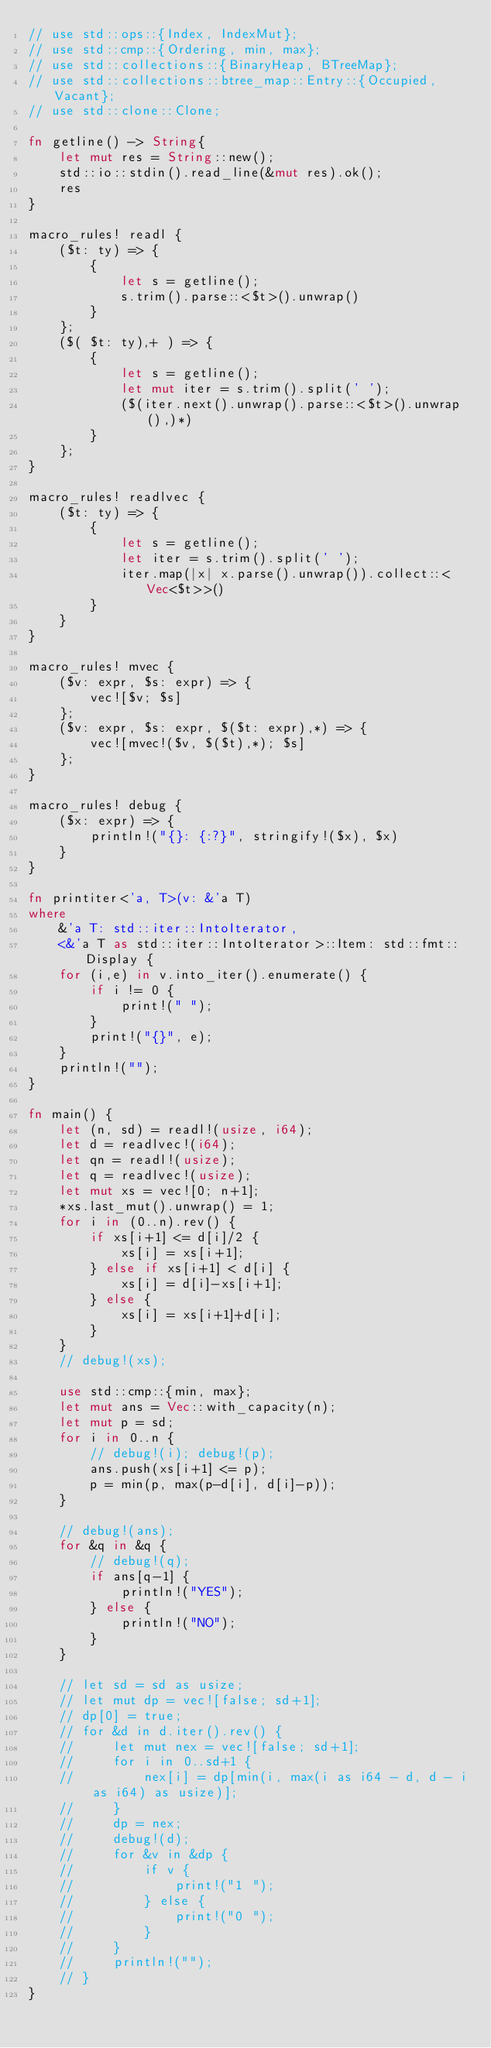Convert code to text. <code><loc_0><loc_0><loc_500><loc_500><_Rust_>// use std::ops::{Index, IndexMut};
// use std::cmp::{Ordering, min, max};
// use std::collections::{BinaryHeap, BTreeMap};
// use std::collections::btree_map::Entry::{Occupied, Vacant};
// use std::clone::Clone;

fn getline() -> String{
    let mut res = String::new();
    std::io::stdin().read_line(&mut res).ok();
    res
}

macro_rules! readl {
    ($t: ty) => {
        {
            let s = getline();
            s.trim().parse::<$t>().unwrap()
        }
    };
    ($( $t: ty),+ ) => {
        {
            let s = getline();
            let mut iter = s.trim().split(' ');
            ($(iter.next().unwrap().parse::<$t>().unwrap(),)*) 
        }
    };
}

macro_rules! readlvec {
    ($t: ty) => {
        {
            let s = getline();
            let iter = s.trim().split(' ');
            iter.map(|x| x.parse().unwrap()).collect::<Vec<$t>>()
        }
    }
}

macro_rules! mvec {
    ($v: expr, $s: expr) => {
        vec![$v; $s]
    };
    ($v: expr, $s: expr, $($t: expr),*) => {
        vec![mvec!($v, $($t),*); $s]
    };
}

macro_rules! debug {
    ($x: expr) => {
        println!("{}: {:?}", stringify!($x), $x)
    }
}

fn printiter<'a, T>(v: &'a T)
where
    &'a T: std::iter::IntoIterator, 
    <&'a T as std::iter::IntoIterator>::Item: std::fmt::Display {
    for (i,e) in v.into_iter().enumerate() {
        if i != 0 {
            print!(" ");
        }
        print!("{}", e);
    }
    println!("");
}

fn main() {
    let (n, sd) = readl!(usize, i64);
    let d = readlvec!(i64);
    let qn = readl!(usize);
    let q = readlvec!(usize);
    let mut xs = vec![0; n+1];
    *xs.last_mut().unwrap() = 1;
    for i in (0..n).rev() {
        if xs[i+1] <= d[i]/2 {
            xs[i] = xs[i+1];
        } else if xs[i+1] < d[i] {
            xs[i] = d[i]-xs[i+1];
        } else {
            xs[i] = xs[i+1]+d[i];
        }
    }
    // debug!(xs);

    use std::cmp::{min, max};
    let mut ans = Vec::with_capacity(n);
    let mut p = sd;
    for i in 0..n {
        // debug!(i); debug!(p);
        ans.push(xs[i+1] <= p);
        p = min(p, max(p-d[i], d[i]-p));
    }

    // debug!(ans);
    for &q in &q {
        // debug!(q);
        if ans[q-1] {
            println!("YES");
        } else {
            println!("NO");
        }
    }

    // let sd = sd as usize;
    // let mut dp = vec![false; sd+1];
    // dp[0] = true;
    // for &d in d.iter().rev() {
    //     let mut nex = vec![false; sd+1];
    //     for i in 0..sd+1 {
    //         nex[i] = dp[min(i, max(i as i64 - d, d - i as i64) as usize)];
    //     }
    //     dp = nex;
    //     debug!(d);
    //     for &v in &dp {
    //         if v {
    //             print!("1 ");
    //         } else {
    //             print!("0 ");
    //         }
    //     }
    //     println!("");
    // }
}

</code> 